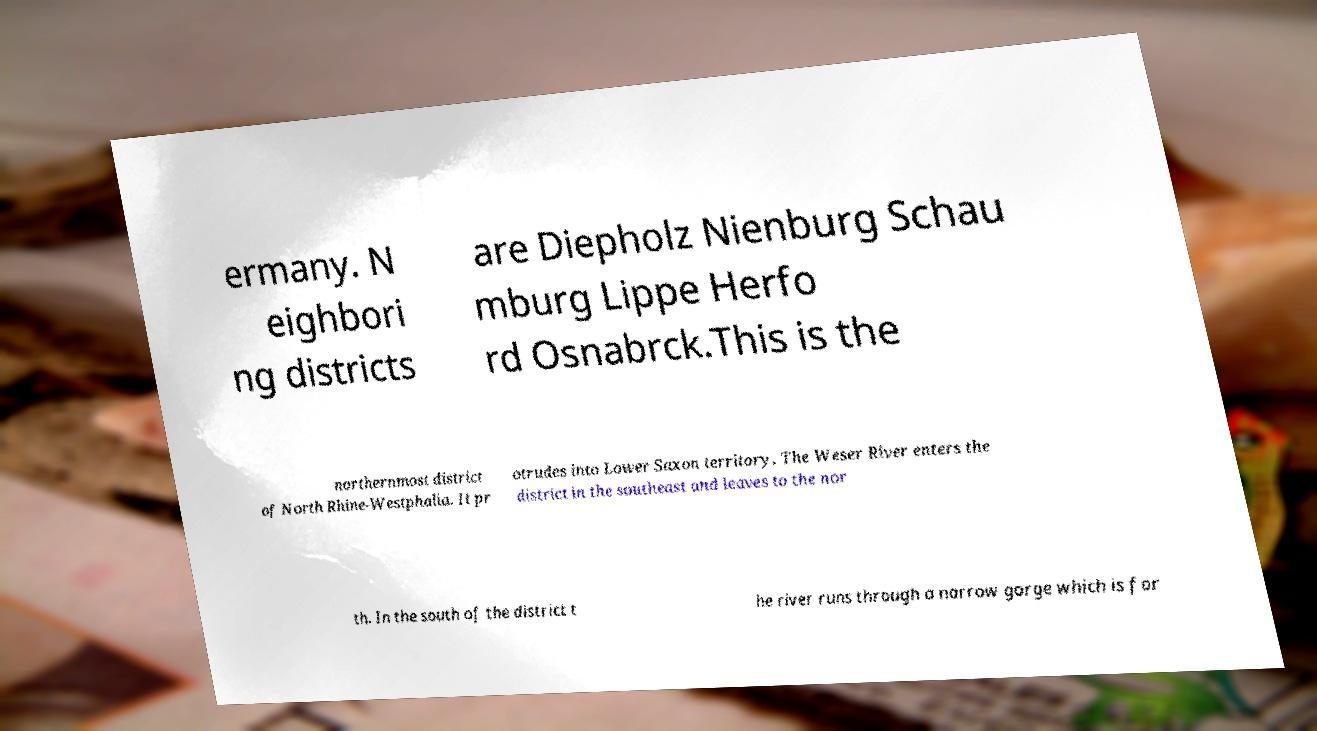What messages or text are displayed in this image? I need them in a readable, typed format. ermany. N eighbori ng districts are Diepholz Nienburg Schau mburg Lippe Herfo rd Osnabrck.This is the northernmost district of North Rhine-Westphalia. It pr otrudes into Lower Saxon territory. The Weser River enters the district in the southeast and leaves to the nor th. In the south of the district t he river runs through a narrow gorge which is for 